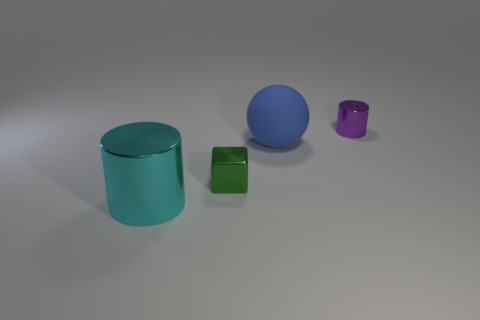What number of things are shiny objects behind the cyan metallic cylinder or tiny things that are left of the purple shiny thing?
Your response must be concise. 2. The object that is in front of the purple object and right of the small shiny block is what color?
Your response must be concise. Blue. Are there more large purple objects than tiny green metallic things?
Your answer should be compact. No. There is a big thing behind the big metallic cylinder; is its shape the same as the big cyan object?
Offer a terse response. No. How many rubber things are green objects or big blue balls?
Make the answer very short. 1. Are there any cubes made of the same material as the small purple cylinder?
Your response must be concise. Yes. What is the material of the big cylinder?
Keep it short and to the point. Metal. There is a small shiny object that is behind the tiny metallic thing to the left of the metal object that is behind the large blue sphere; what is its shape?
Your answer should be compact. Cylinder. Is the number of metal cubes in front of the green metallic object greater than the number of green blocks?
Give a very brief answer. No. There is a large cyan metallic object; does it have the same shape as the small thing on the right side of the small block?
Provide a succinct answer. Yes. 